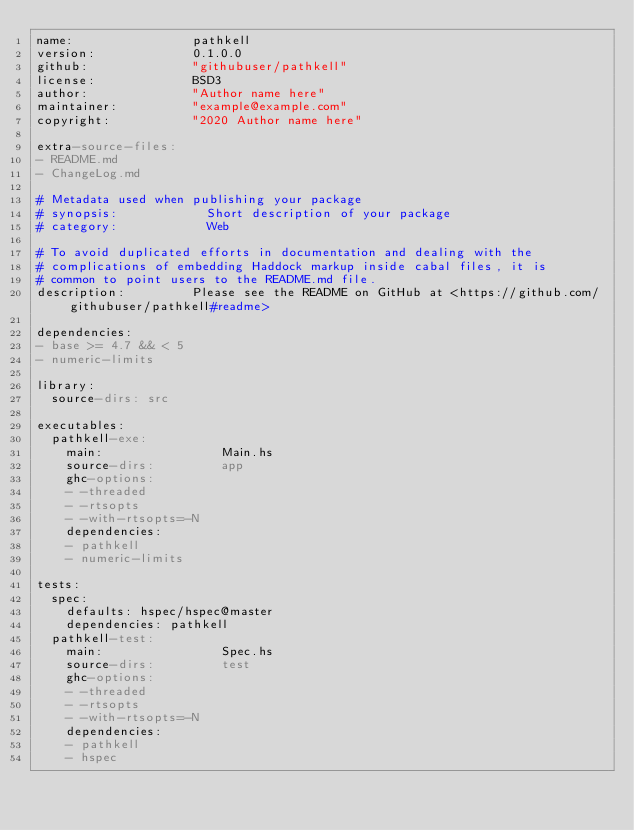Convert code to text. <code><loc_0><loc_0><loc_500><loc_500><_YAML_>name:                pathkell
version:             0.1.0.0
github:              "githubuser/pathkell"
license:             BSD3
author:              "Author name here"
maintainer:          "example@example.com"
copyright:           "2020 Author name here"

extra-source-files:
- README.md
- ChangeLog.md

# Metadata used when publishing your package
# synopsis:            Short description of your package
# category:            Web

# To avoid duplicated efforts in documentation and dealing with the
# complications of embedding Haddock markup inside cabal files, it is
# common to point users to the README.md file.
description:         Please see the README on GitHub at <https://github.com/githubuser/pathkell#readme>

dependencies:
- base >= 4.7 && < 5
- numeric-limits

library:
  source-dirs: src

executables:
  pathkell-exe:
    main:                Main.hs
    source-dirs:         app
    ghc-options:
    - -threaded
    - -rtsopts
    - -with-rtsopts=-N
    dependencies:
    - pathkell
    - numeric-limits

tests:
  spec:
    defaults: hspec/hspec@master
    dependencies: pathkell
  pathkell-test:
    main:                Spec.hs
    source-dirs:         test
    ghc-options:
    - -threaded
    - -rtsopts
    - -with-rtsopts=-N
    dependencies:
    - pathkell
    - hspec
</code> 